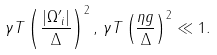<formula> <loc_0><loc_0><loc_500><loc_500>\gamma T \left ( \frac { | { \Omega ^ { \prime } } _ { i } | } { \Delta } \right ) ^ { 2 } , \, \gamma T \left ( \frac { \eta g } { \Delta } \right ) ^ { 2 } \ll 1 .</formula> 